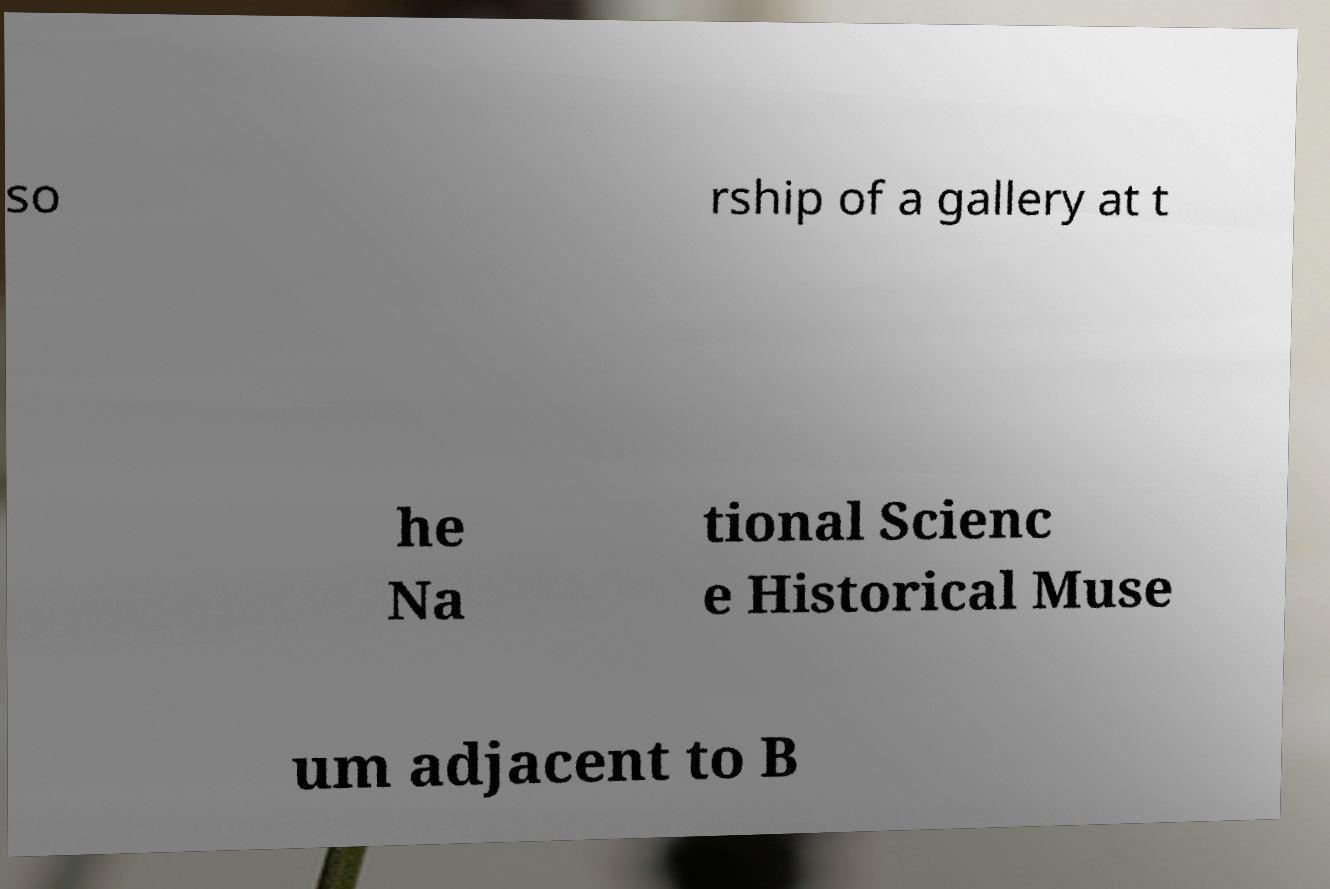There's text embedded in this image that I need extracted. Can you transcribe it verbatim? so rship of a gallery at t he Na tional Scienc e Historical Muse um adjacent to B 